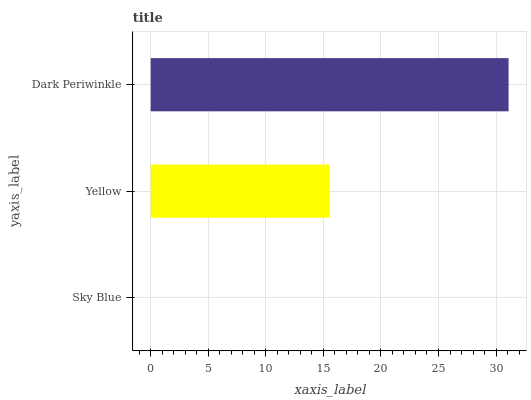Is Sky Blue the minimum?
Answer yes or no. Yes. Is Dark Periwinkle the maximum?
Answer yes or no. Yes. Is Yellow the minimum?
Answer yes or no. No. Is Yellow the maximum?
Answer yes or no. No. Is Yellow greater than Sky Blue?
Answer yes or no. Yes. Is Sky Blue less than Yellow?
Answer yes or no. Yes. Is Sky Blue greater than Yellow?
Answer yes or no. No. Is Yellow less than Sky Blue?
Answer yes or no. No. Is Yellow the high median?
Answer yes or no. Yes. Is Yellow the low median?
Answer yes or no. Yes. Is Dark Periwinkle the high median?
Answer yes or no. No. Is Sky Blue the low median?
Answer yes or no. No. 